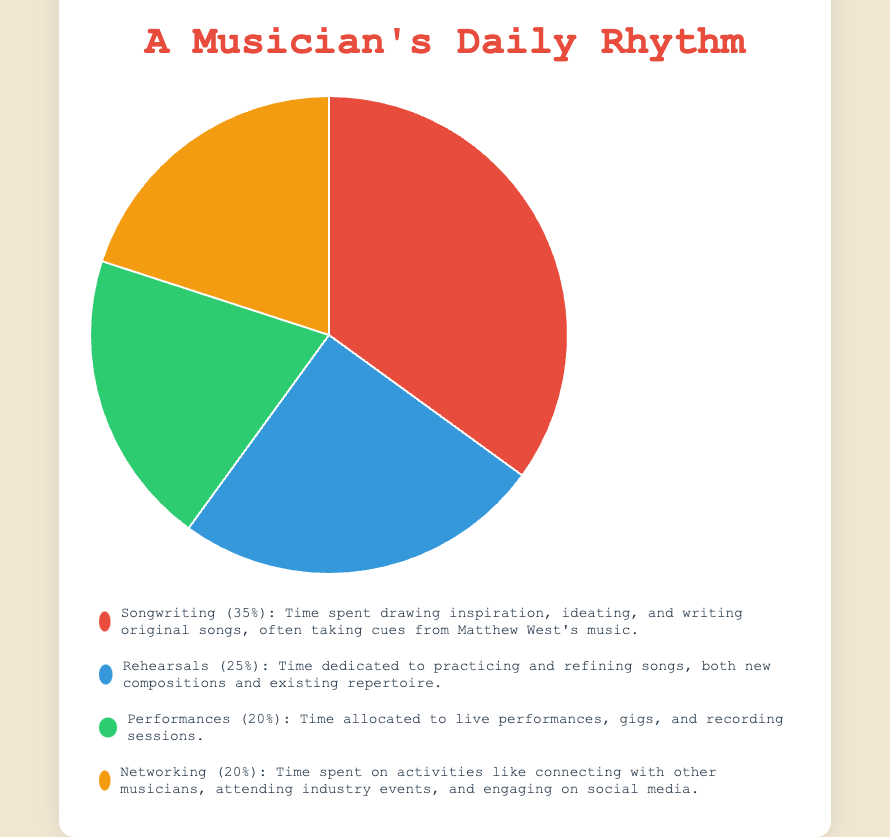What percentage of the day does the musician spend on songwriting? The chart shows that "Songwriting" takes up 35% of the musician's daily time allocation.
Answer: 35% How much more time does the musician spend on songwriting compared to networking? The musician spends 35% on songwriting and 20% on networking. The difference is 35% - 20% = 15%.
Answer: 15% Which two activities have equal time allocation? The chart indicates that both "Performances" and "Networking" each occupy 20% of the musician's daily time allocation.
Answer: Performances and Networking What is the total percentage spent on rehearsals and performances combined? "Rehearsals" take up 25% and "Performances" take up 20%. Adding these together, the total is 25% + 20% = 45%.
Answer: 45% Identify the activity that takes the least amount of time and state its percentage. The chart shows that both "Performances" and "Networking" occupy 20% of the musician's daily time allocation, which is the least.
Answer: Performances and Networking (20%) How does the time dedicated to rehearsals compare to the time spent on performances? The musician spends 25% of their time on rehearsals and 20% on performances. Therefore, more time is spent on rehearsals than performances by 25% - 20% = 5%.
Answer: 5% more on rehearsals What are the activities the musician spends more than 20% of their time on? The chart indicates that the musician spends 35% on songwriting and 25% on rehearsals, both of which are greater than 20%.
Answer: Songwriting and Rehearsals If the musician decided to allocate equal time for all activities, what would each new activity percentage be and how much more or less time would be spent on networking? The total percentage is 100%, and there are 4 activities. Equally, each activity would take 100% / 4 = 25%. Networking currently takes 20%, so the musician would spend 25% - 20% = 5% more on networking.
Answer: 25%, 5% more on networking 